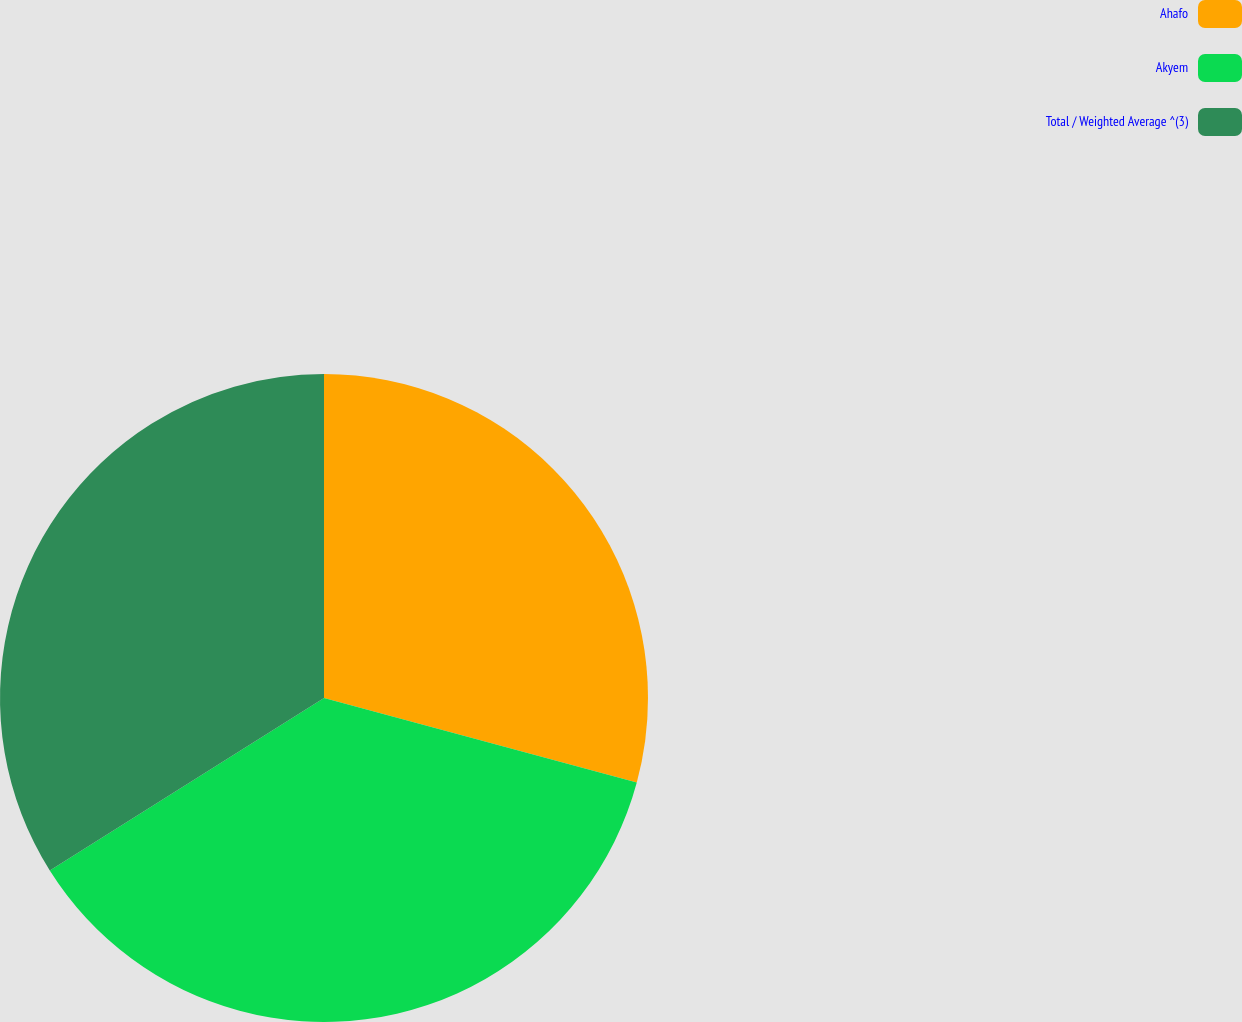Convert chart to OTSL. <chart><loc_0><loc_0><loc_500><loc_500><pie_chart><fcel>Ahafo<fcel>Akyem<fcel>Total / Weighted Average ^(3)<nl><fcel>29.2%<fcel>36.86%<fcel>33.94%<nl></chart> 